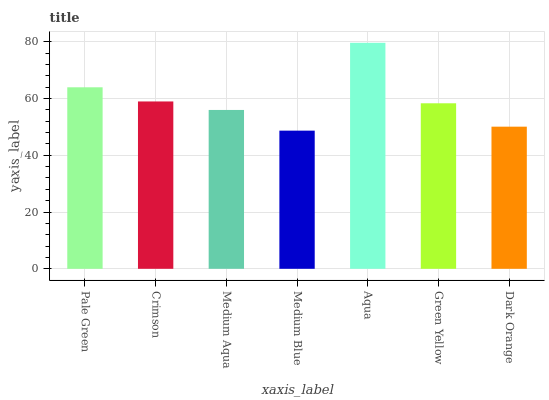Is Medium Blue the minimum?
Answer yes or no. Yes. Is Aqua the maximum?
Answer yes or no. Yes. Is Crimson the minimum?
Answer yes or no. No. Is Crimson the maximum?
Answer yes or no. No. Is Pale Green greater than Crimson?
Answer yes or no. Yes. Is Crimson less than Pale Green?
Answer yes or no. Yes. Is Crimson greater than Pale Green?
Answer yes or no. No. Is Pale Green less than Crimson?
Answer yes or no. No. Is Green Yellow the high median?
Answer yes or no. Yes. Is Green Yellow the low median?
Answer yes or no. Yes. Is Dark Orange the high median?
Answer yes or no. No. Is Crimson the low median?
Answer yes or no. No. 